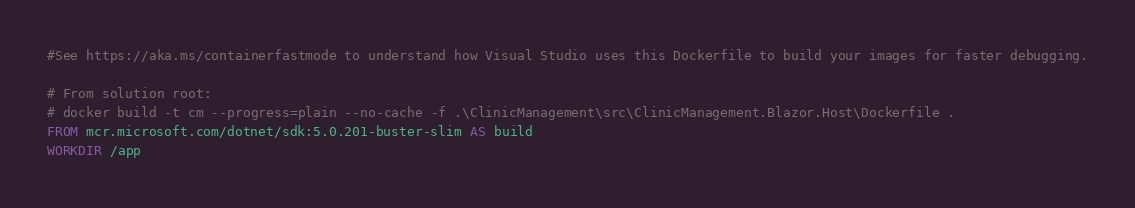Convert code to text. <code><loc_0><loc_0><loc_500><loc_500><_Dockerfile_>#See https://aka.ms/containerfastmode to understand how Visual Studio uses this Dockerfile to build your images for faster debugging.

# From solution root:
# docker build -t cm --progress=plain --no-cache -f .\ClinicManagement\src\ClinicManagement.Blazor.Host\Dockerfile .
FROM mcr.microsoft.com/dotnet/sdk:5.0.201-buster-slim AS build
WORKDIR /app
</code> 